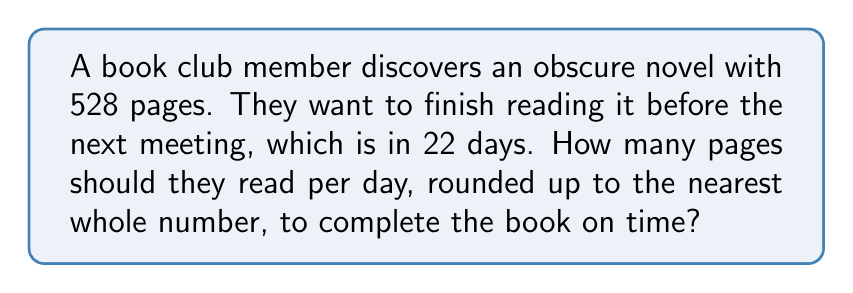Show me your answer to this math problem. Let's approach this step-by-step:

1) First, we need to set up the equation:
   $$ \text{Pages per day} \times \text{Number of days} = \text{Total pages} $$

2) We know the total number of pages (528) and the number of days (22). Let's call the pages per day $x$:
   $$ x \times 22 = 528 $$

3) To solve for $x$, we divide both sides by 22:
   $$ x = \frac{528}{22} $$

4) Let's perform this division:
   $$ x = 24 $$

5) However, the question asks for the result rounded up to the nearest whole number. Since 24 is already a whole number, we don't need to round up.

Therefore, the book club member needs to read 24 pages per day to finish the book in time for the next meeting.
Answer: 24 pages 